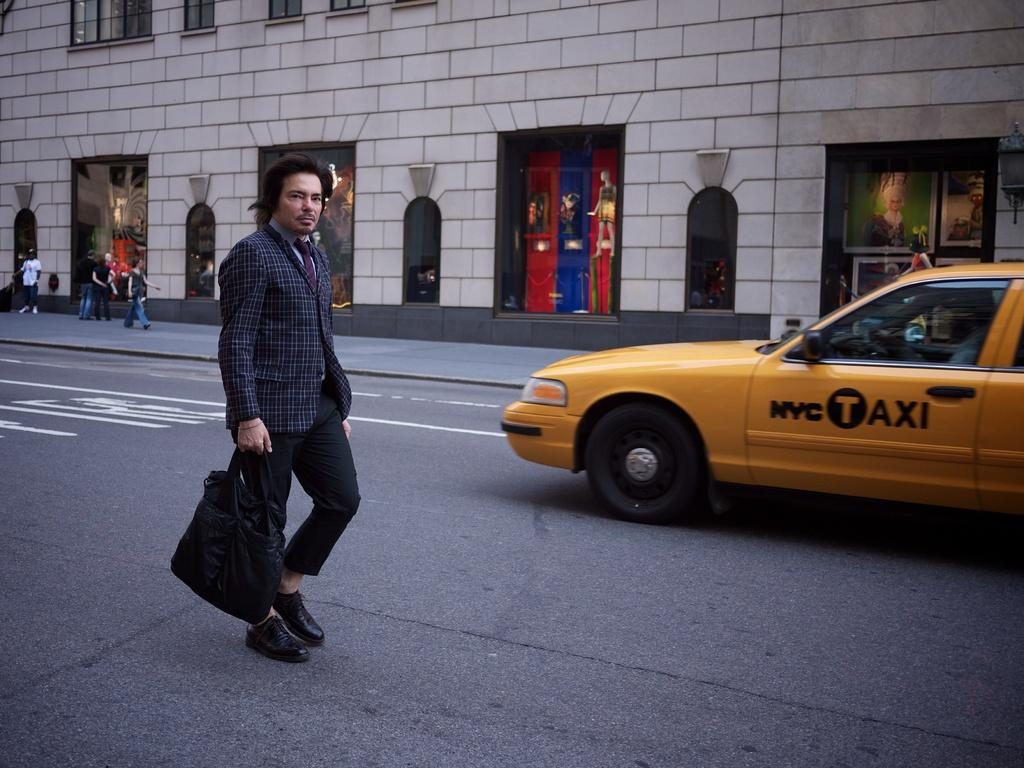Provide a one-sentence caption for the provided image. A man in a plaid jacket is walking near a NYC Taxi. 